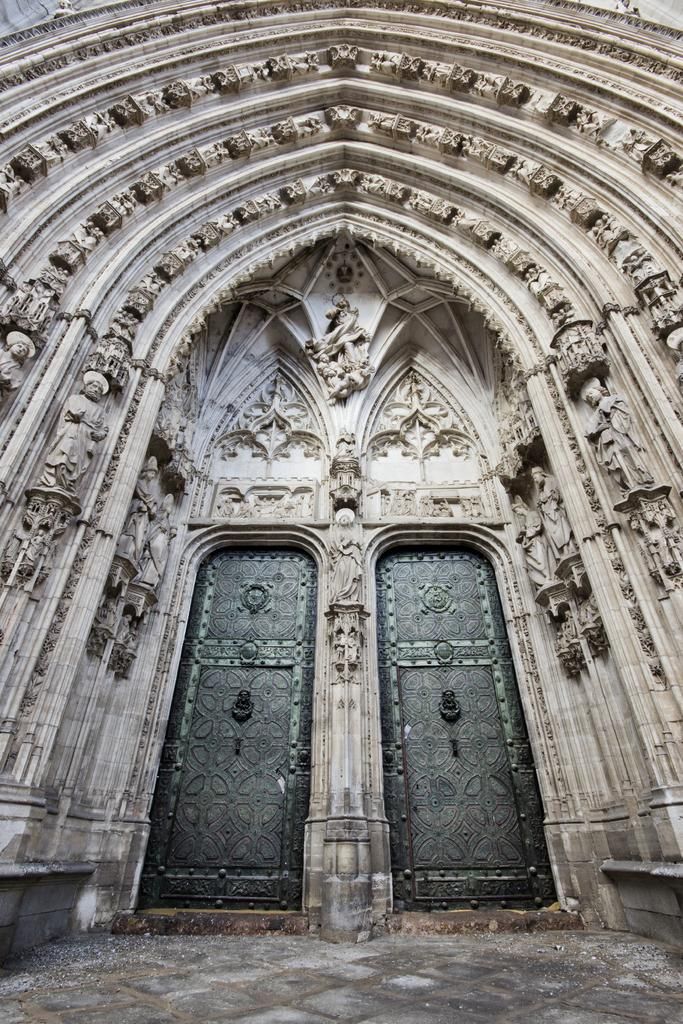What type of structure is shown in the image? The image depicts an ancient building. Are there any specific features of the building that can be seen? Yes, there are doors and designs on the walls of the building. What other objects or elements are present in the image? There are statues in the image. What can be seen at the bottom of the image? The ground is visible at the bottom of the image. How many girls are holding onto the rail in the image? There are no girls or rails present in the image; it features an ancient building with doors, statues, and designs on the walls. 